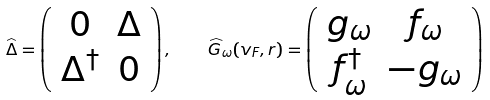Convert formula to latex. <formula><loc_0><loc_0><loc_500><loc_500>\widehat { \Delta } = \left ( \begin{array} { c c } 0 & \Delta \\ \Delta ^ { \dagger } & 0 \end{array} \right ) , \quad \widehat { G } _ { \omega } ( { v } _ { F } , { r } ) = \left ( \begin{array} { c c } g _ { \omega } & f _ { \omega } \\ f _ { \omega } ^ { \dagger } & - g _ { \omega } \end{array} \right )</formula> 